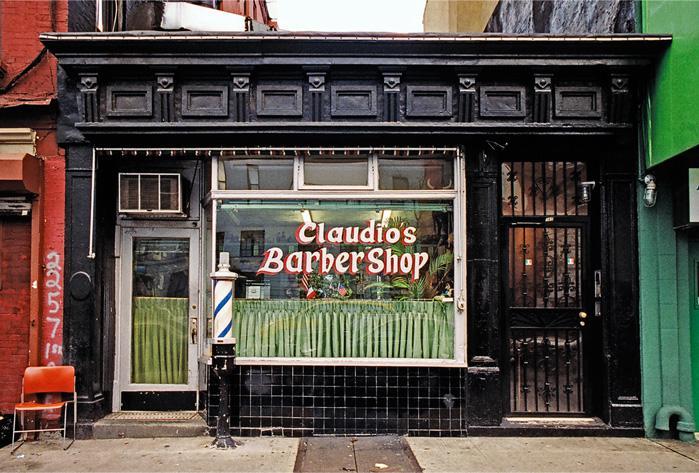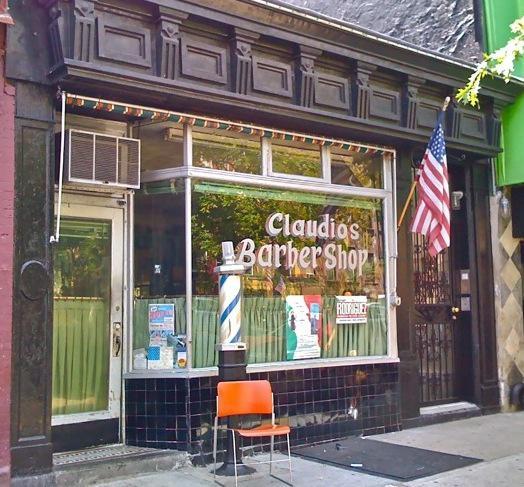The first image is the image on the left, the second image is the image on the right. For the images shown, is this caption "Each barber shop displays at least one barber pole." true? Answer yes or no. Yes. 